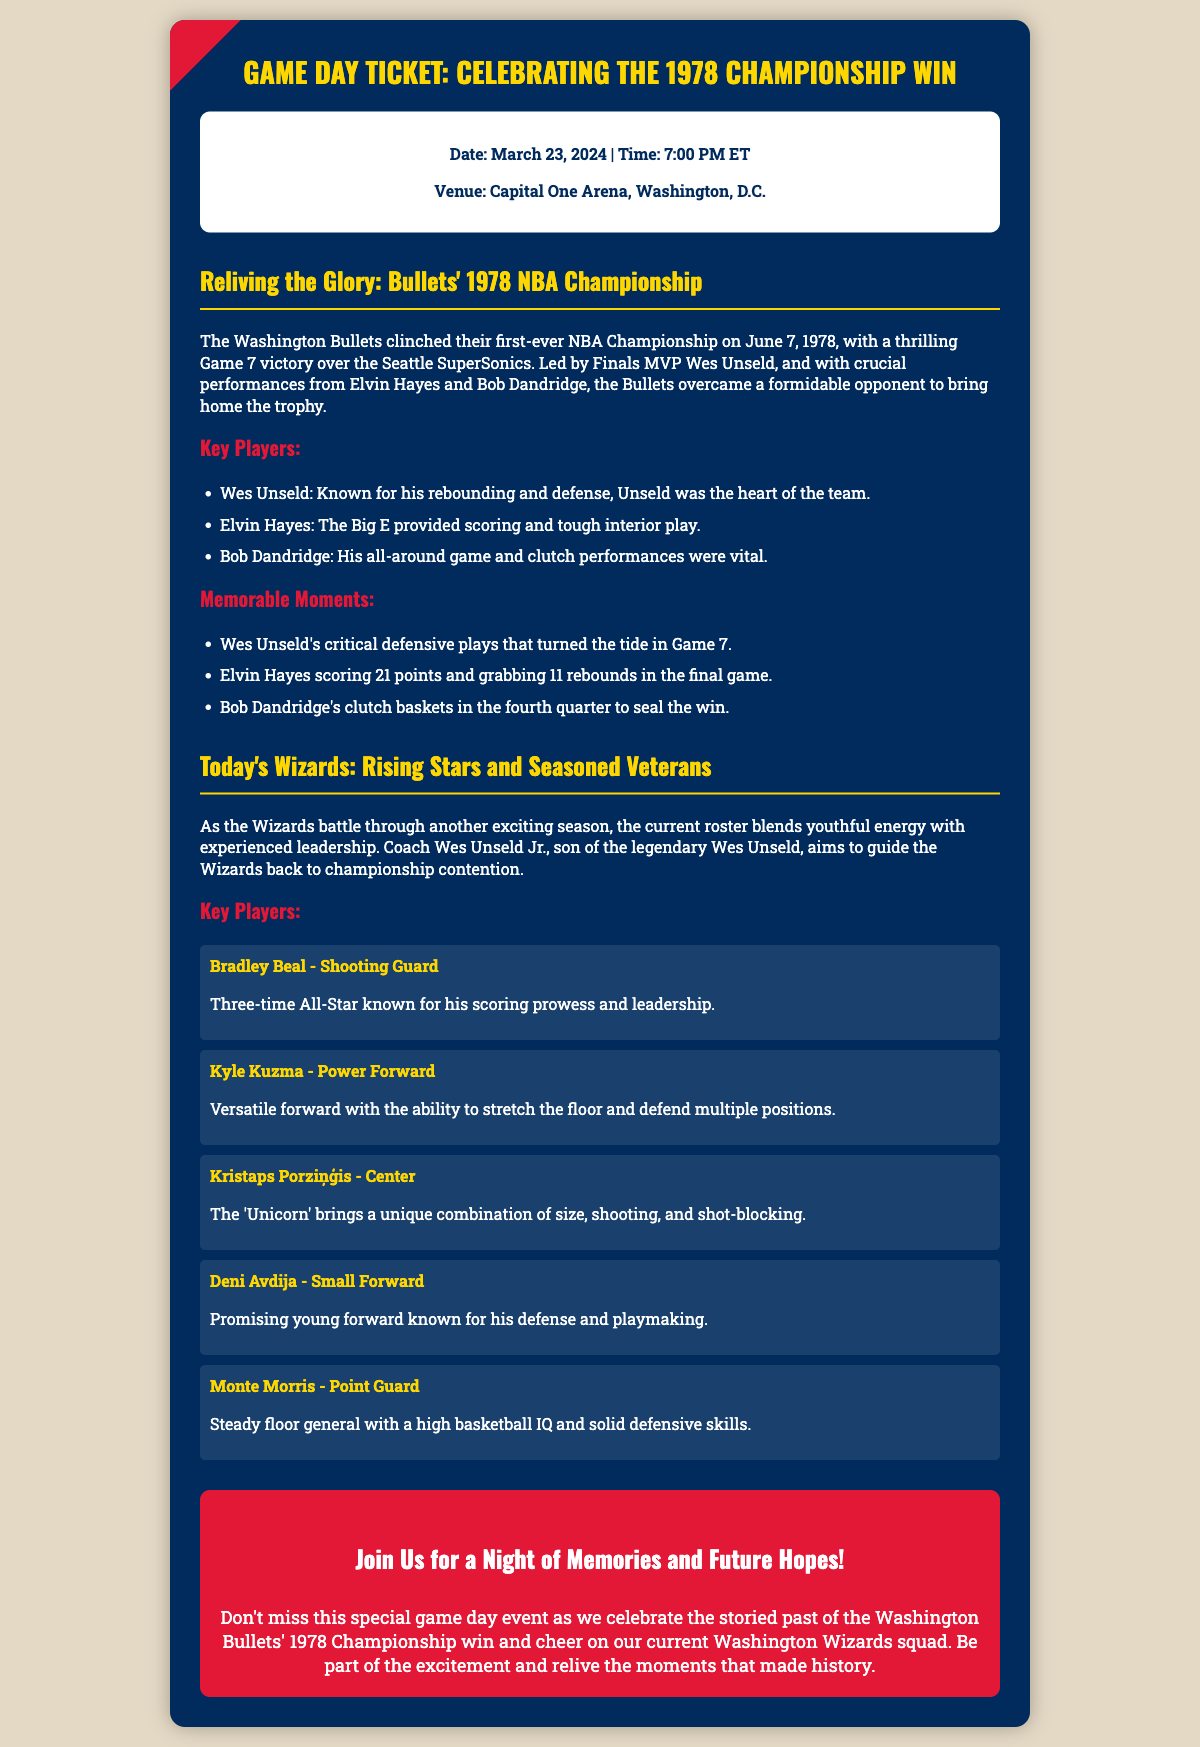what is the date of the game? The date of the game is explicitly mentioned in the document as March 23, 2024.
Answer: March 23, 2024 who won the 1978 Championship? The document states that the Washington Bullets won their first-ever NBA Championship in 1978.
Answer: Washington Bullets who was the Finals MVP in 1978? The document highlights Wes Unseld as the Finals MVP of the 1978 Championship.
Answer: Wes Unseld how many points did Elvin Hayes score in the final game? The document provides specific performance details, stating Elvin Hayes scored 21 points in the final game.
Answer: 21 points what position does Bradley Beal play? The document classifies Bradley Beal as a Shooting Guard, revealing his role on the team.
Answer: Shooting Guard which venue will host the game? The document mentions that the game will take place at Capital One Arena in Washington, D.C.
Answer: Capital One Arena who is the current head coach of the Wizards? The document mentions that Wes Unseld Jr. is the current head coach of the Wizards.
Answer: Wes Unseld Jr what year did the Bullets win the championship? The document specifies that the Bullets won the championship in the year 1978.
Answer: 1978 what is the primary theme of the Game Day Ticket? The document's title and content indicate that the primary theme is celebrating the 1978 Championship win.
Answer: Celebrating the 1978 Championship Win 